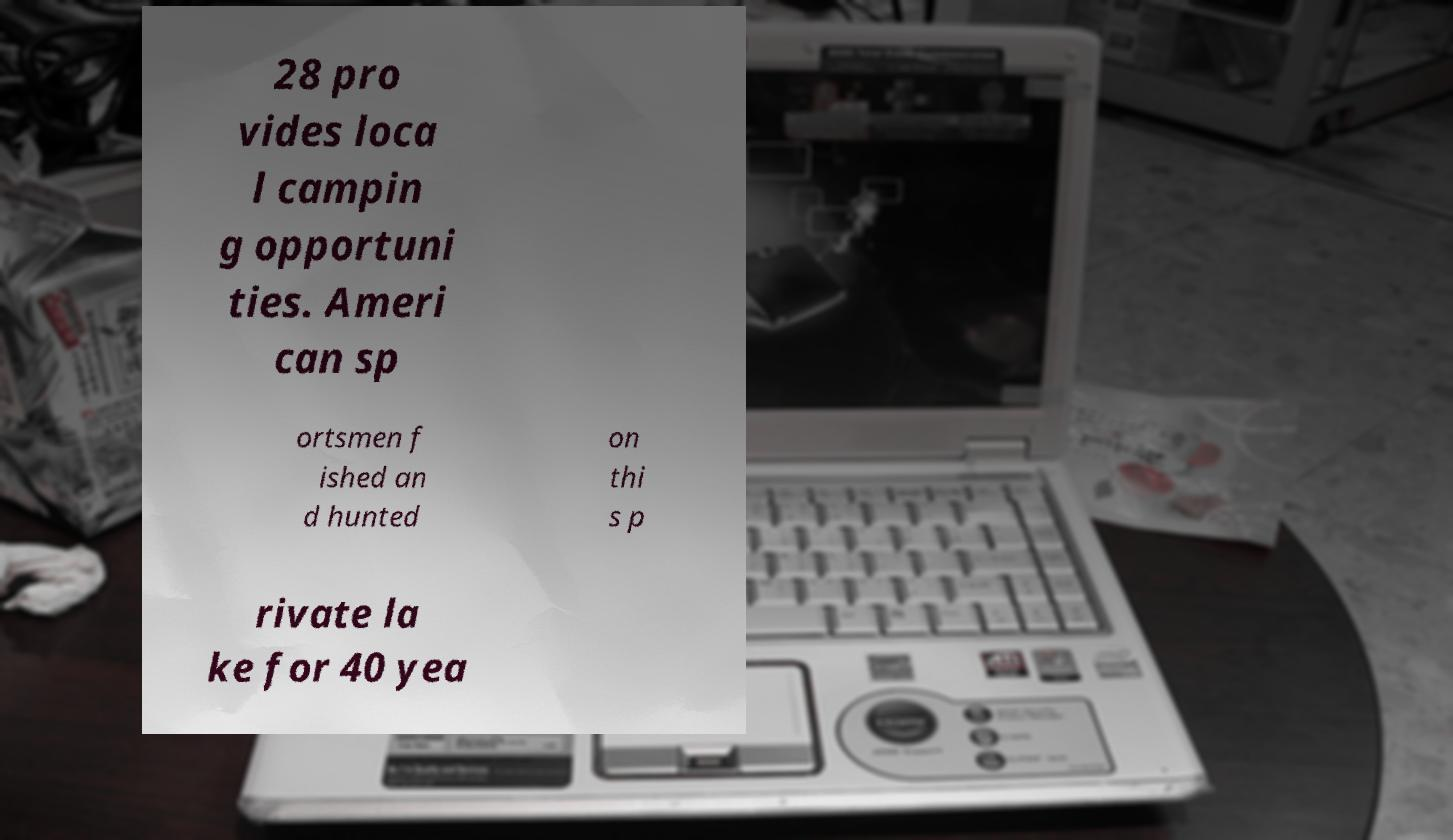What messages or text are displayed in this image? I need them in a readable, typed format. 28 pro vides loca l campin g opportuni ties. Ameri can sp ortsmen f ished an d hunted on thi s p rivate la ke for 40 yea 